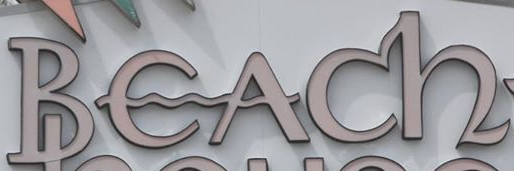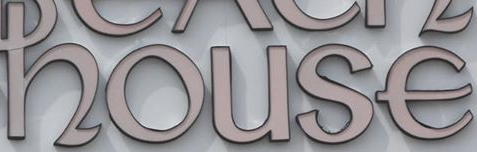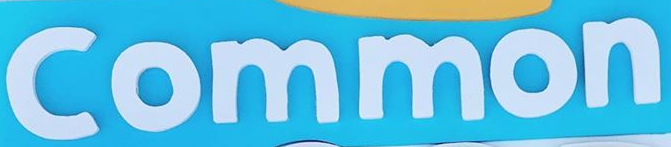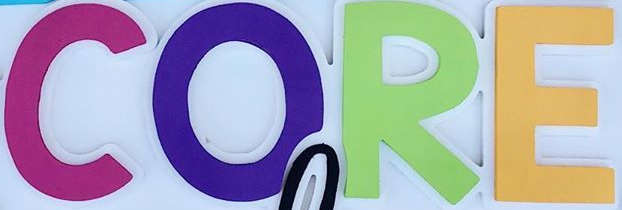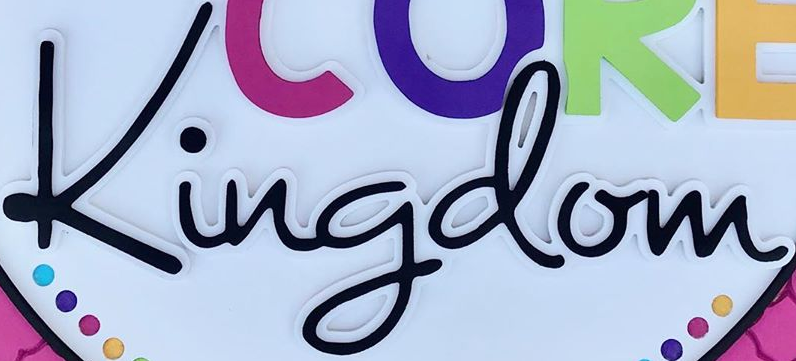What text appears in these images from left to right, separated by a semicolon? Beach; house; Common; CORE; Kingdom 